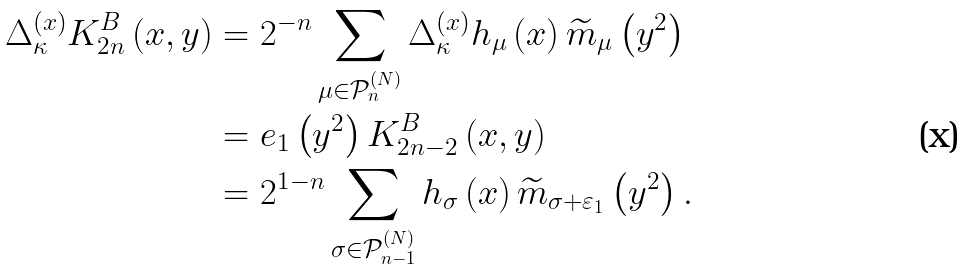Convert formula to latex. <formula><loc_0><loc_0><loc_500><loc_500>\Delta _ { \kappa } ^ { \left ( x \right ) } K _ { 2 n } ^ { B } \left ( x , y \right ) & = 2 ^ { - n } \sum _ { \mu \in \mathcal { P } _ { n } ^ { \left ( N \right ) } } \Delta _ { \kappa } ^ { \left ( x \right ) } h _ { \mu } \left ( x \right ) \widetilde { m } _ { \mu } \left ( y ^ { 2 } \right ) \\ & = e _ { 1 } \left ( y ^ { 2 } \right ) K _ { 2 n - 2 } ^ { B } \left ( x , y \right ) \\ & = 2 ^ { 1 - n } \sum _ { \sigma \in \mathcal { P } _ { n - 1 } ^ { \left ( N \right ) } } h _ { \sigma } \left ( x \right ) \widetilde { m } _ { \sigma + \varepsilon _ { 1 } } \left ( y ^ { 2 } \right ) .</formula> 